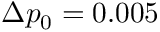Convert formula to latex. <formula><loc_0><loc_0><loc_500><loc_500>\Delta p _ { 0 } = 0 . 0 0 5</formula> 